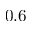Convert formula to latex. <formula><loc_0><loc_0><loc_500><loc_500>0 . 6</formula> 